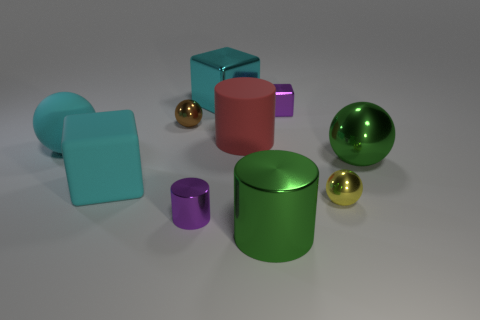Subtract 1 balls. How many balls are left? 3 Subtract all cylinders. How many objects are left? 7 Subtract 0 yellow blocks. How many objects are left? 10 Subtract all big red rubber objects. Subtract all big blocks. How many objects are left? 7 Add 9 tiny brown metal balls. How many tiny brown metal balls are left? 10 Add 6 big spheres. How many big spheres exist? 8 